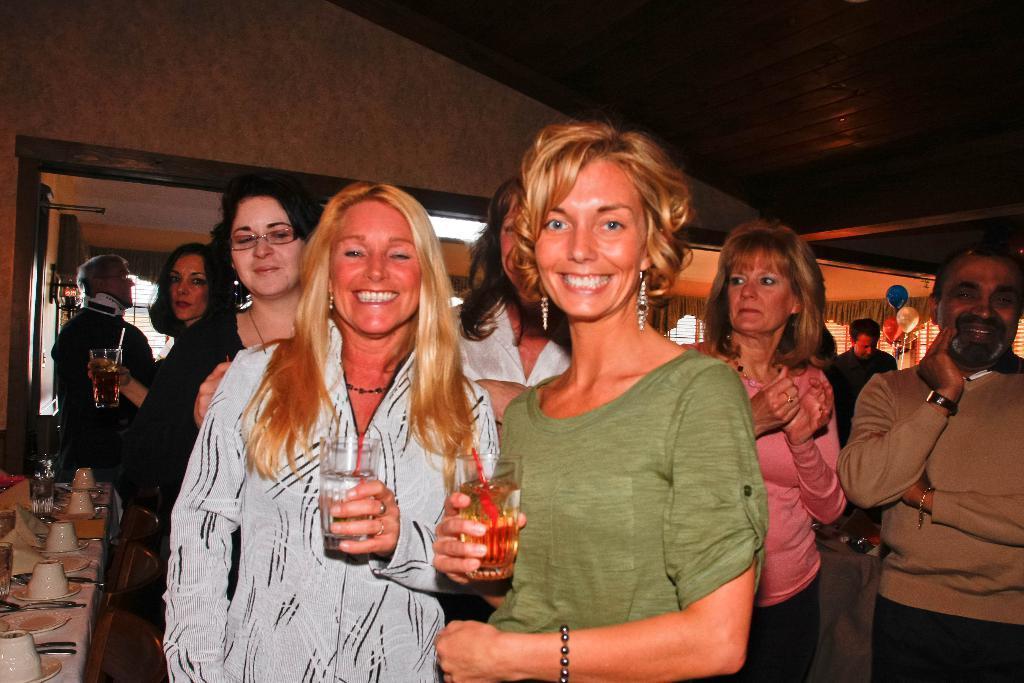Please provide a concise description of this image. In this image, there are a few people. We can see a table covered with a cloth and some objects like plates and bowls are placed on it. We can see the wall with some objects. We can also see some curtains and the window blind. We can also see the roof and some balloons. 